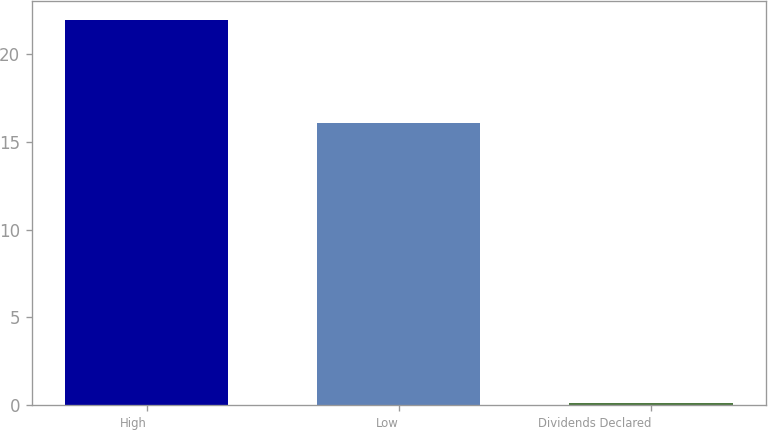Convert chart to OTSL. <chart><loc_0><loc_0><loc_500><loc_500><bar_chart><fcel>High<fcel>Low<fcel>Dividends Declared<nl><fcel>21.95<fcel>16.1<fcel>0.1<nl></chart> 